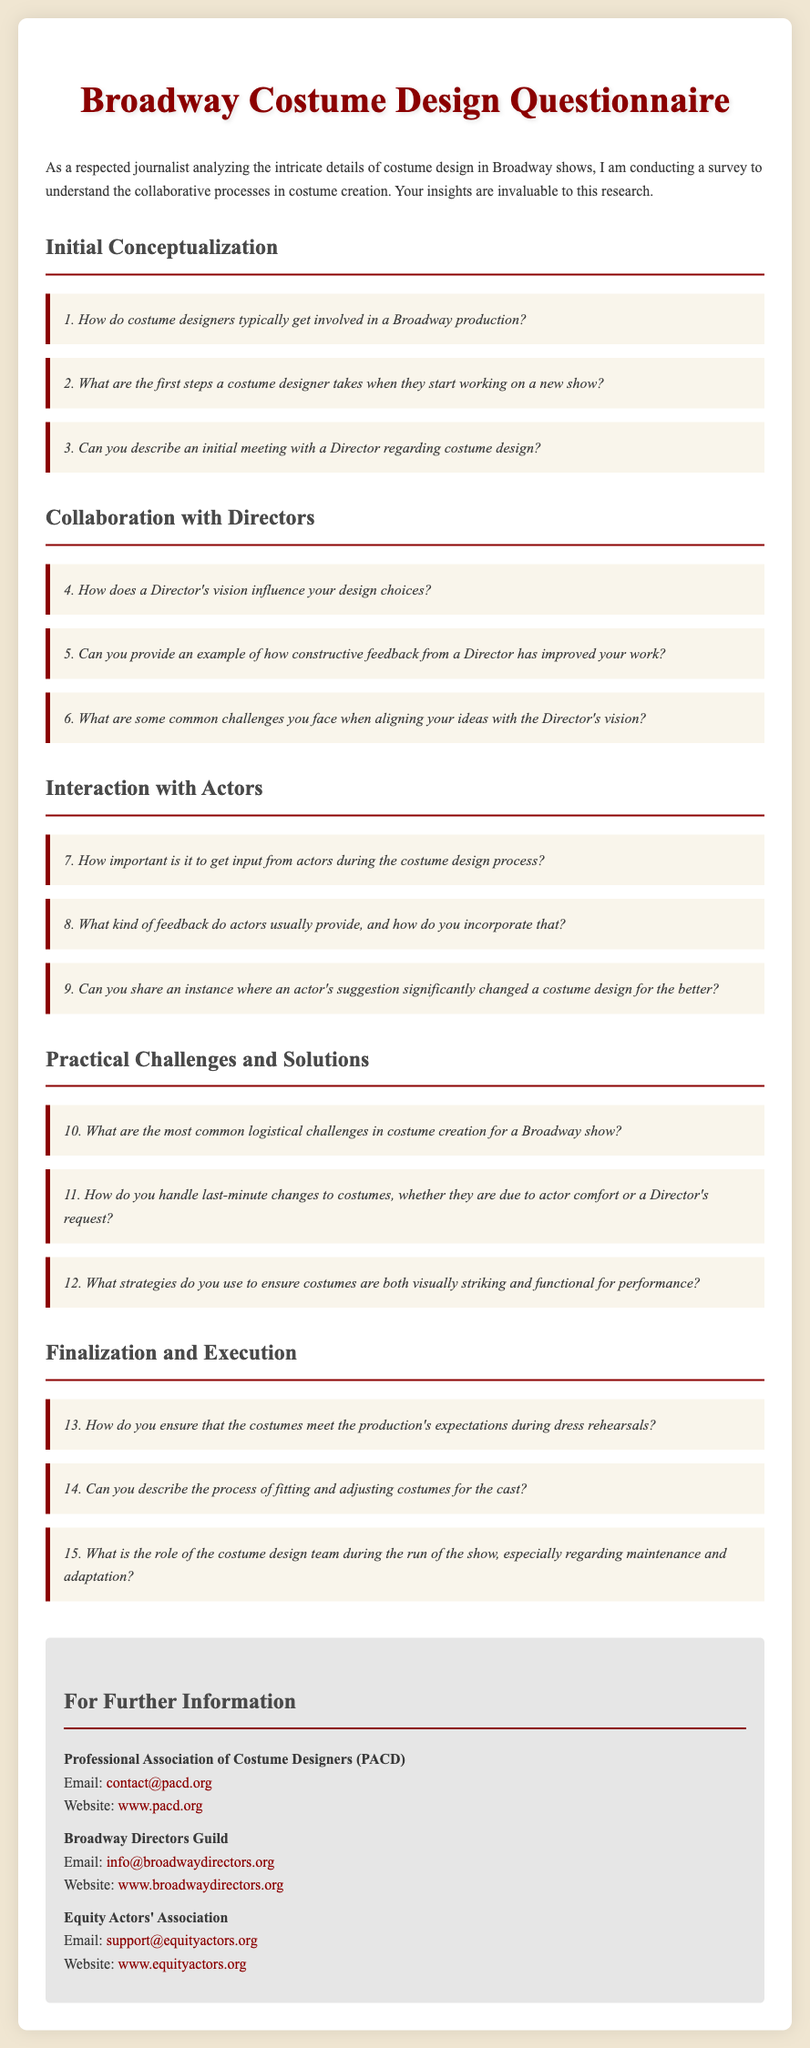What is the title of the document? The document's title appears at the top of the rendered document, indicating its subject.
Answer: Broadway Costume Design Questionnaire How many sections are there in the questionnaire? The document contains multiple sections specified with headings.
Answer: 5 What is the first question in the 'Initial Conceptualization' section? The answer can be found in the list of questions under the specific section.
Answer: How do costume designers typically get involved in a Broadway production? Who can be contacted for further information about costume design? The document lists professional organizations that provide contact details for further inquiries.
Answer: Professional Association of Costume Designers (PACD) What is the background color of the document? The background color is defined in the CSS part of the HTML code, which affects the visual appearance.
Answer: #f0e6d2 How does a Director's vision influence design choices? This is a question within the document that prompts for a feedback topic.
Answer: Short-answer response required What color is used for the section headings? The heading color is specified in the style section of the code.
Answer: #4a4a4a What type of feedback do actors usually provide? This question prompts for a specific type of feedback described in the document.
Answer: Short-answer response required 